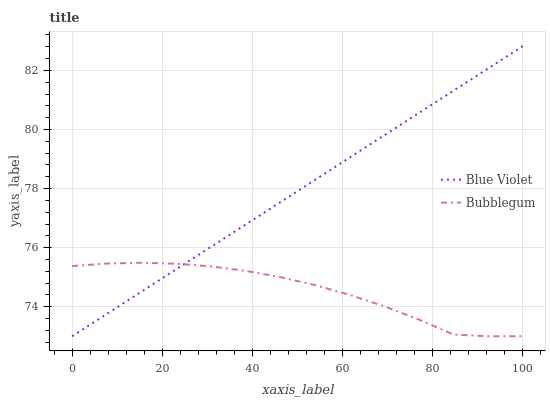Does Bubblegum have the minimum area under the curve?
Answer yes or no. Yes. Does Blue Violet have the maximum area under the curve?
Answer yes or no. Yes. Does Blue Violet have the minimum area under the curve?
Answer yes or no. No. Is Blue Violet the smoothest?
Answer yes or no. Yes. Is Bubblegum the roughest?
Answer yes or no. Yes. Is Blue Violet the roughest?
Answer yes or no. No. Does Bubblegum have the lowest value?
Answer yes or no. Yes. Does Blue Violet have the highest value?
Answer yes or no. Yes. Does Blue Violet intersect Bubblegum?
Answer yes or no. Yes. Is Blue Violet less than Bubblegum?
Answer yes or no. No. Is Blue Violet greater than Bubblegum?
Answer yes or no. No. 